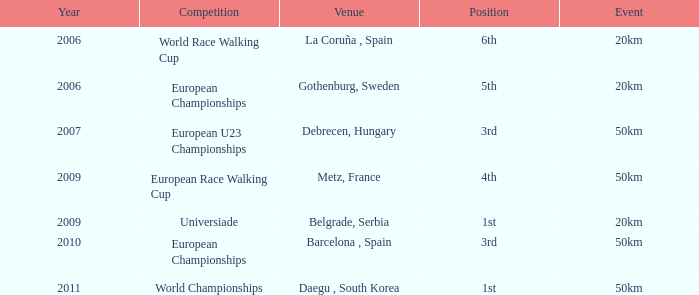What competition holds a 50km event in the year preceding 2010 and involves a position of 3rd place? European U23 Championships. 